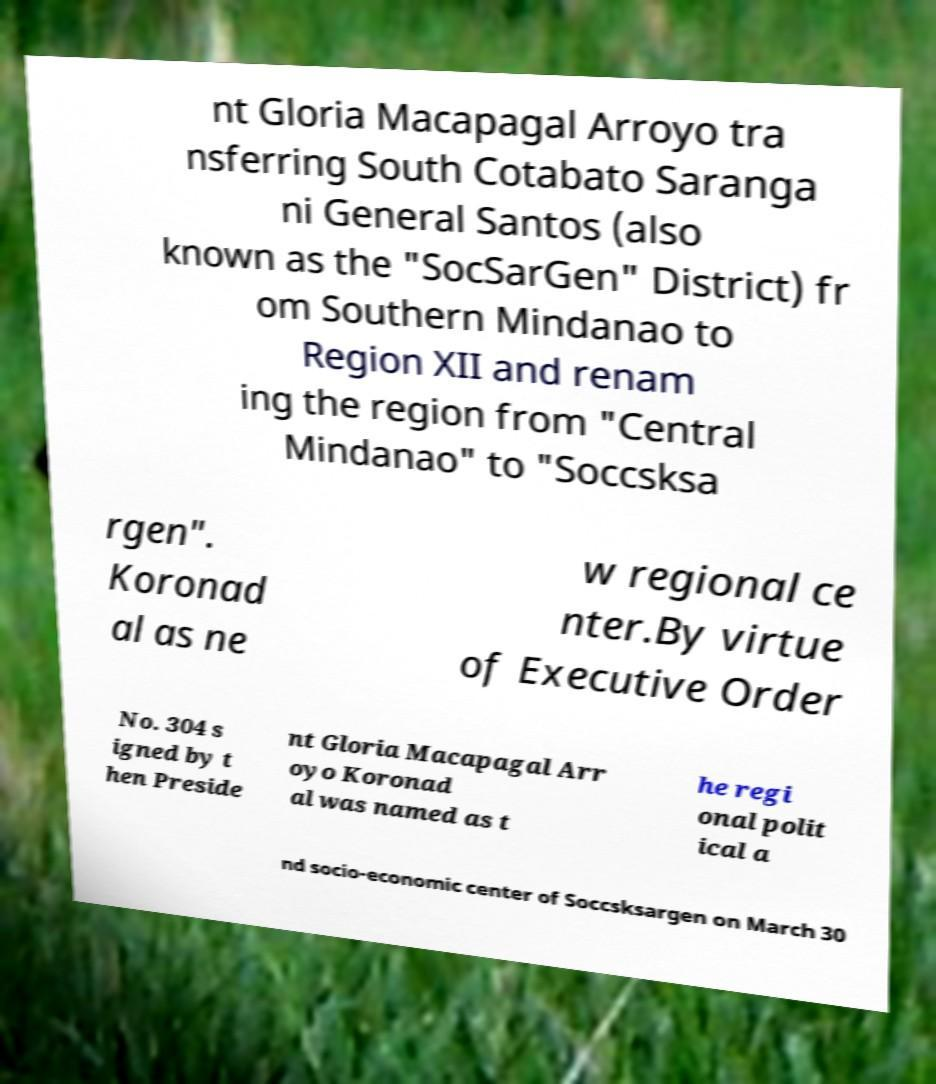What messages or text are displayed in this image? I need them in a readable, typed format. nt Gloria Macapagal Arroyo tra nsferring South Cotabato Saranga ni General Santos (also known as the "SocSarGen" District) fr om Southern Mindanao to Region XII and renam ing the region from "Central Mindanao" to "Soccsksa rgen". Koronad al as ne w regional ce nter.By virtue of Executive Order No. 304 s igned by t hen Preside nt Gloria Macapagal Arr oyo Koronad al was named as t he regi onal polit ical a nd socio-economic center of Soccsksargen on March 30 